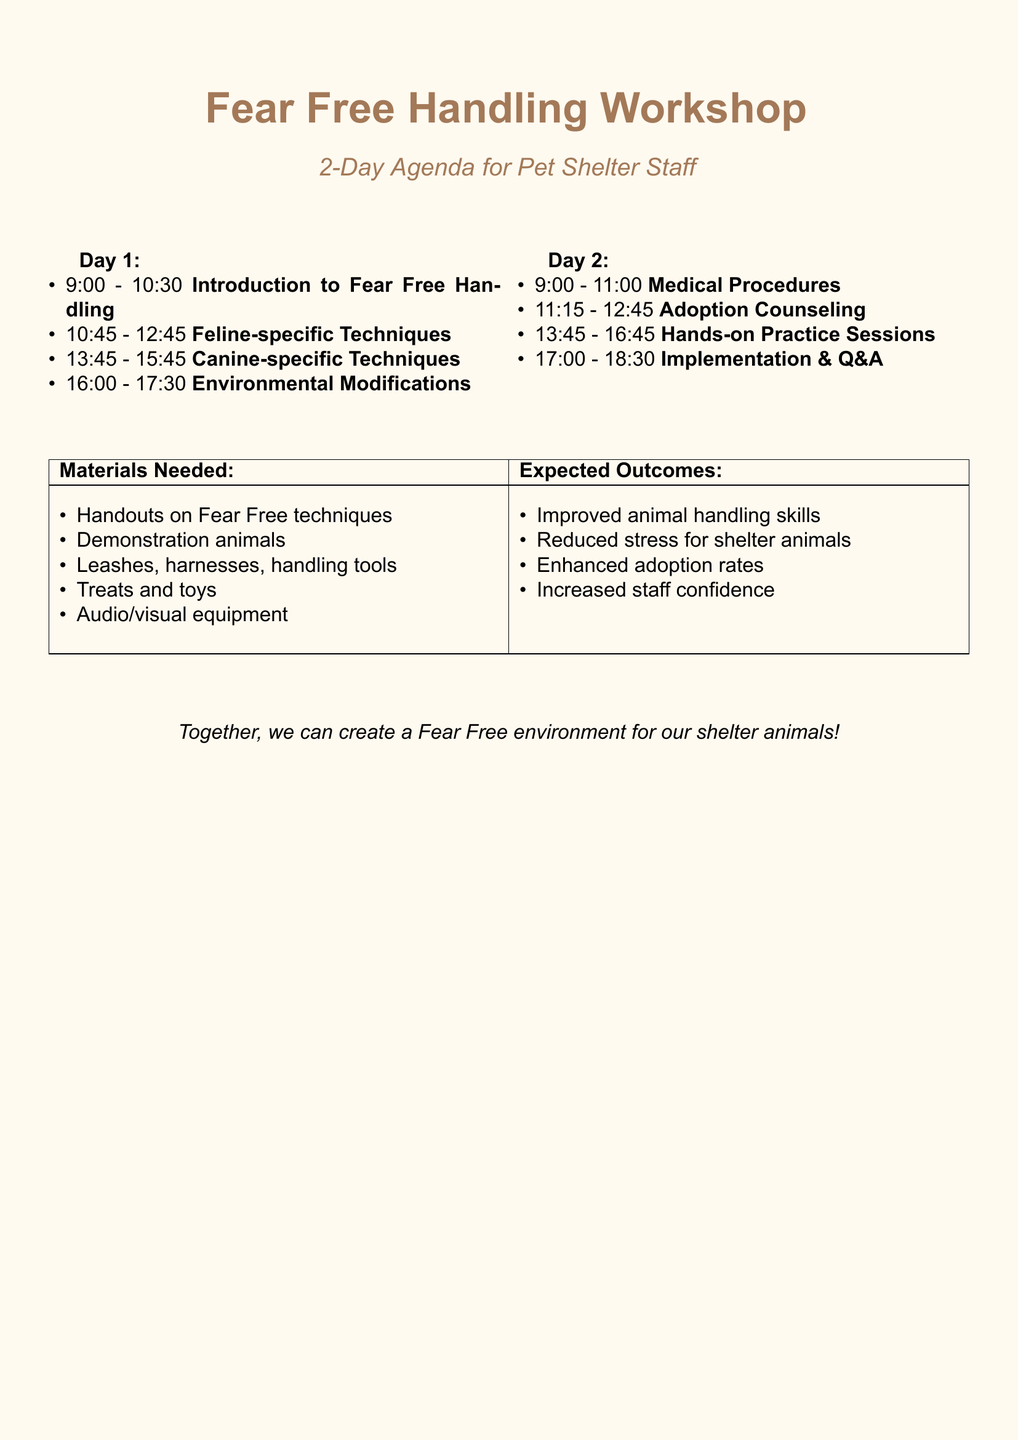What is the title of the workshop? The title of the workshop is provided at the beginning of the document.
Answer: Implementing Fear Free Handling Techniques in Daily Shelter Operations Who is the speaker for the Introduction to Fear Free Handling session? The document lists the speaker for each session, which is relevant for identifying expertise.
Answer: Dr. Sarah Johnson How long is the Hands-on Practice Sessions? The duration of each session is clearly indicated in the workshop agenda.
Answer: 180 minutes What is one of the expected outcomes of the workshop? The expected outcomes are listed at the end of the document, focusing on the benefits of the workshop.
Answer: Improved animal handling skills What type of materials are needed for the workshop? The materials needed are specifically listed in a tabular format, reflecting preparation requirements.
Answer: Handouts on Fear Free techniques How many sessions are focused on canine-specific techniques? A count of the session titles can be made to understand the emphasis on dogs.
Answer: One session What is the duration of the Q&A and Workshop Conclusion session? The agenda specifies the duration for each session, reinforcing time management in the training.
Answer: 60 minutes Who is the facilitator for the Q&A and Workshop Conclusion session? The facilitators are listed for each session, providing insight into who will lead the discussions.
Answer: Dr. Sarah Johnson 